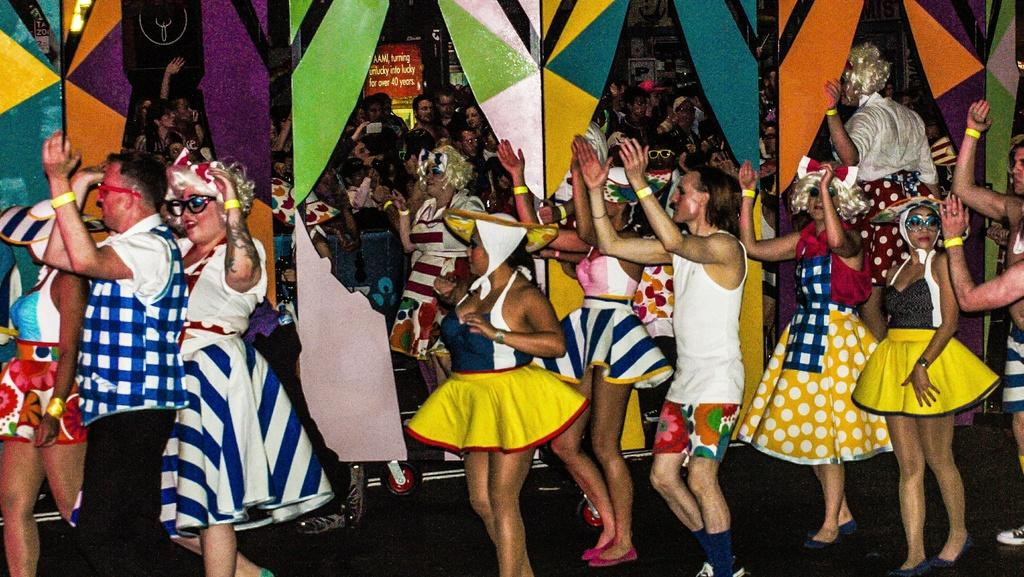Who is present in the image? There are people in the image. What are the people wearing? The people are wearing drama costumes. What are the people doing in the image? The people are dancing. Where is the dancing taking place? The dancing is taking place in a hall. What can be seen in the background of the image? There is a wall visible in the image. What type of humor can be seen in the image? There is no humor present in the image; it depicts people dancing in drama costumes. What discovery was made during the dance in the image? There is no discovery mentioned or depicted in the image; it shows people dancing in a hall. 